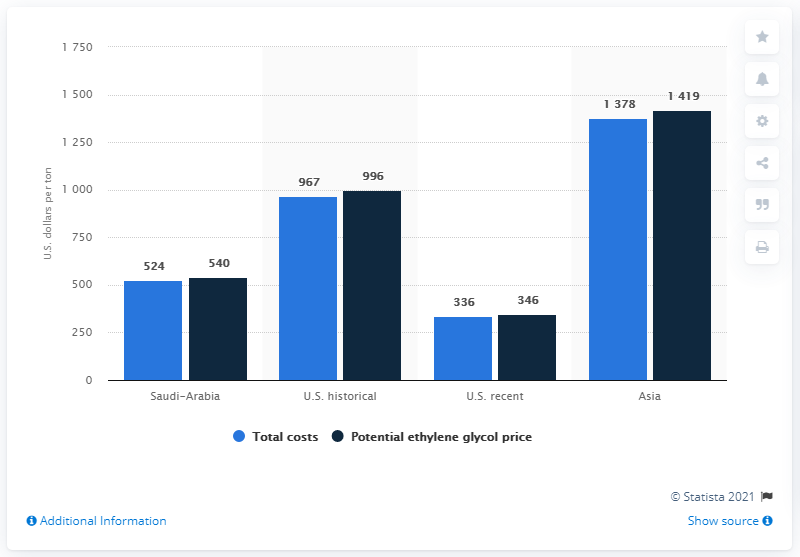Indicate a few pertinent items in this graphic. In 2012, the potential price per ton of ethylene glycol was estimated to be approximately 346 US dollars. The total cost of ethylene glycol per ton in the United States in 2012 was 336... 